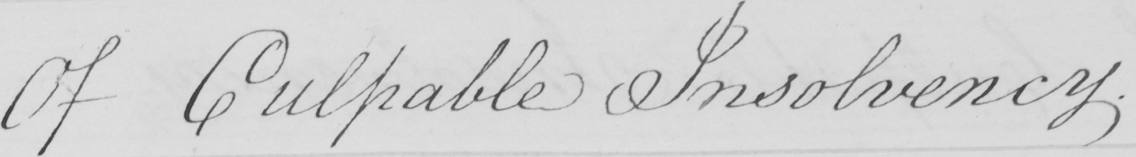Transcribe the text shown in this historical manuscript line. Of Culpable Insolvency . 